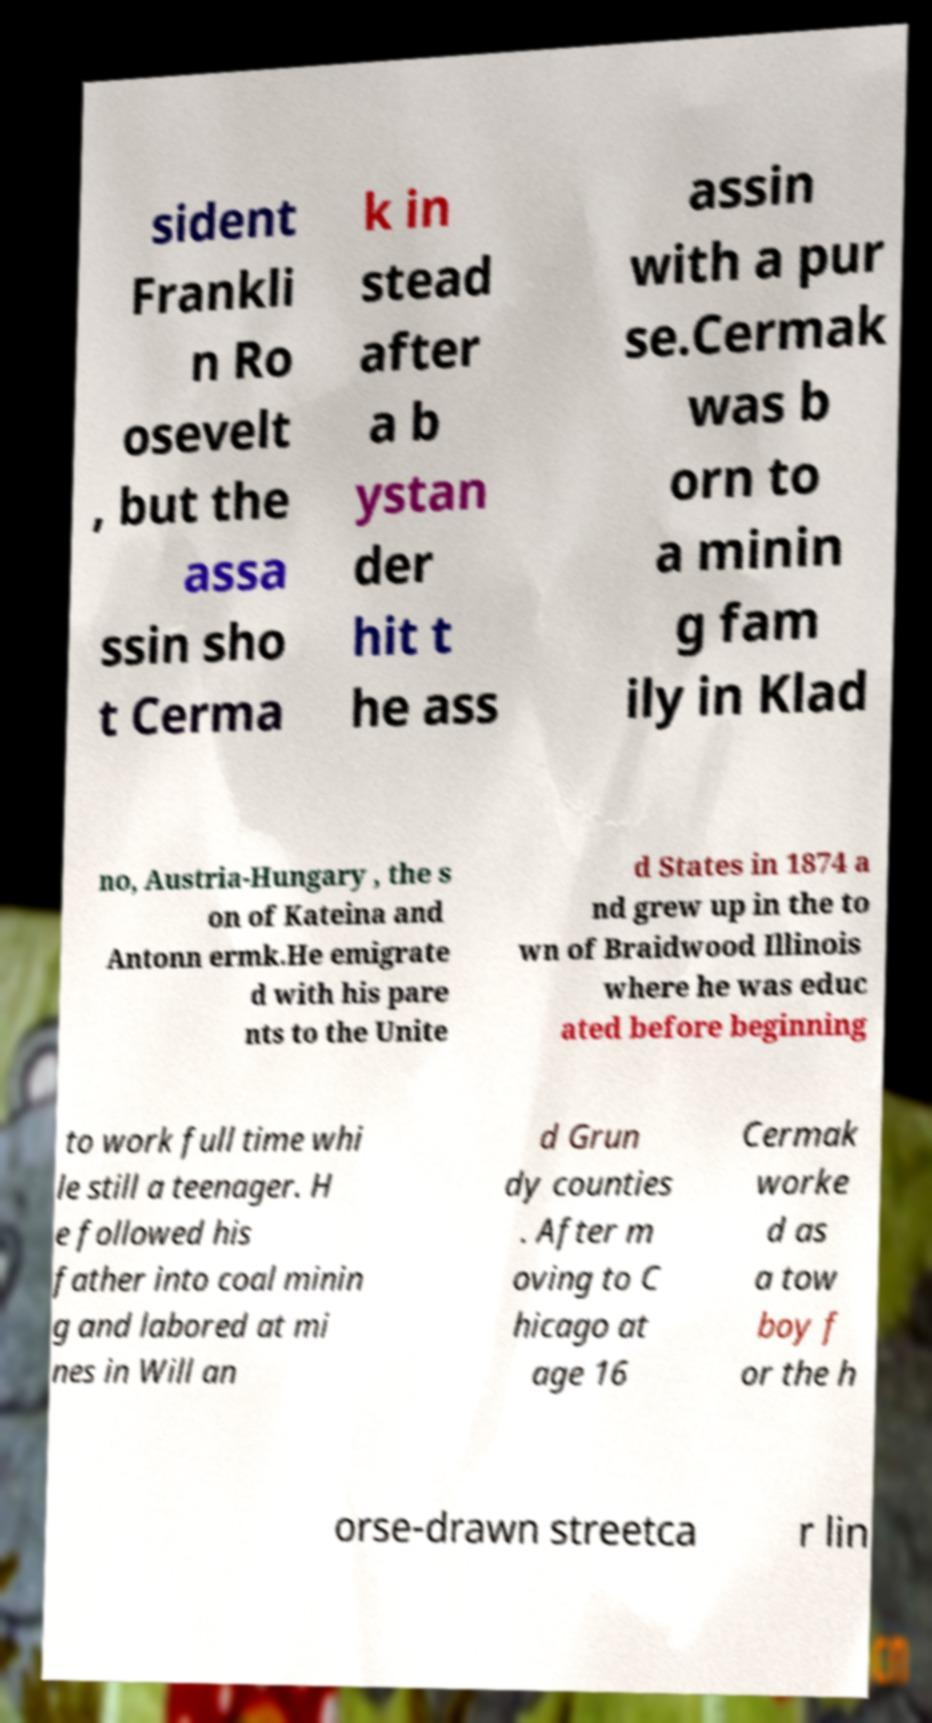Could you extract and type out the text from this image? sident Frankli n Ro osevelt , but the assa ssin sho t Cerma k in stead after a b ystan der hit t he ass assin with a pur se.Cermak was b orn to a minin g fam ily in Klad no, Austria-Hungary , the s on of Kateina and Antonn ermk.He emigrate d with his pare nts to the Unite d States in 1874 a nd grew up in the to wn of Braidwood Illinois where he was educ ated before beginning to work full time whi le still a teenager. H e followed his father into coal minin g and labored at mi nes in Will an d Grun dy counties . After m oving to C hicago at age 16 Cermak worke d as a tow boy f or the h orse-drawn streetca r lin 